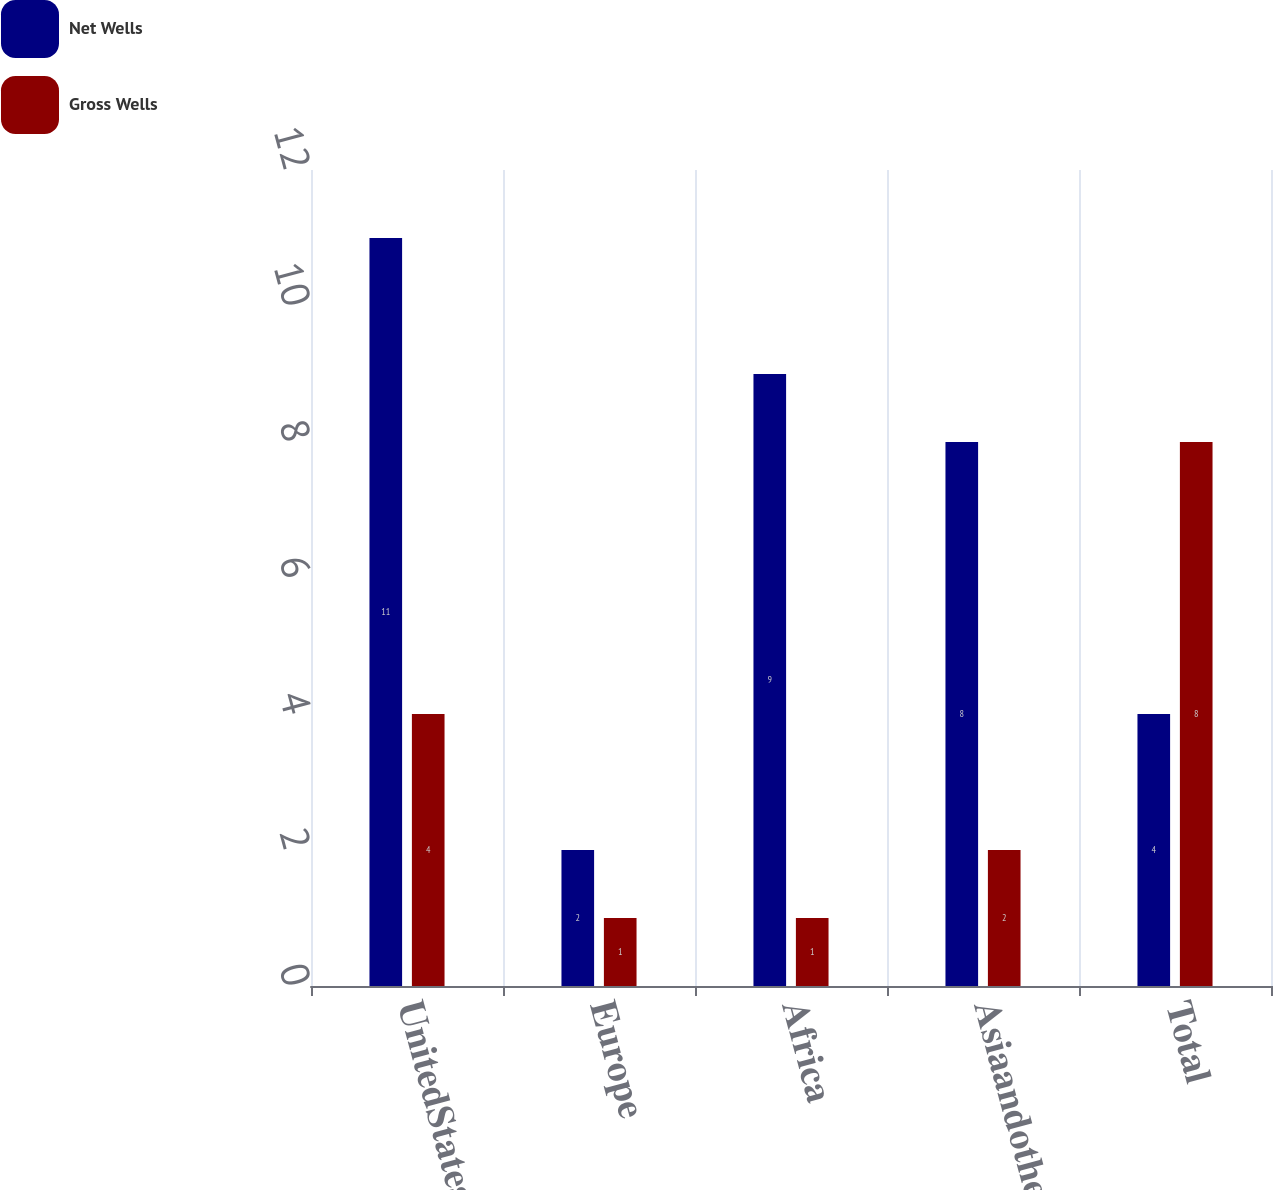Convert chart to OTSL. <chart><loc_0><loc_0><loc_500><loc_500><stacked_bar_chart><ecel><fcel>UnitedStates<fcel>Europe<fcel>Africa<fcel>Asiaandother<fcel>Total<nl><fcel>Net Wells<fcel>11<fcel>2<fcel>9<fcel>8<fcel>4<nl><fcel>Gross Wells<fcel>4<fcel>1<fcel>1<fcel>2<fcel>8<nl></chart> 